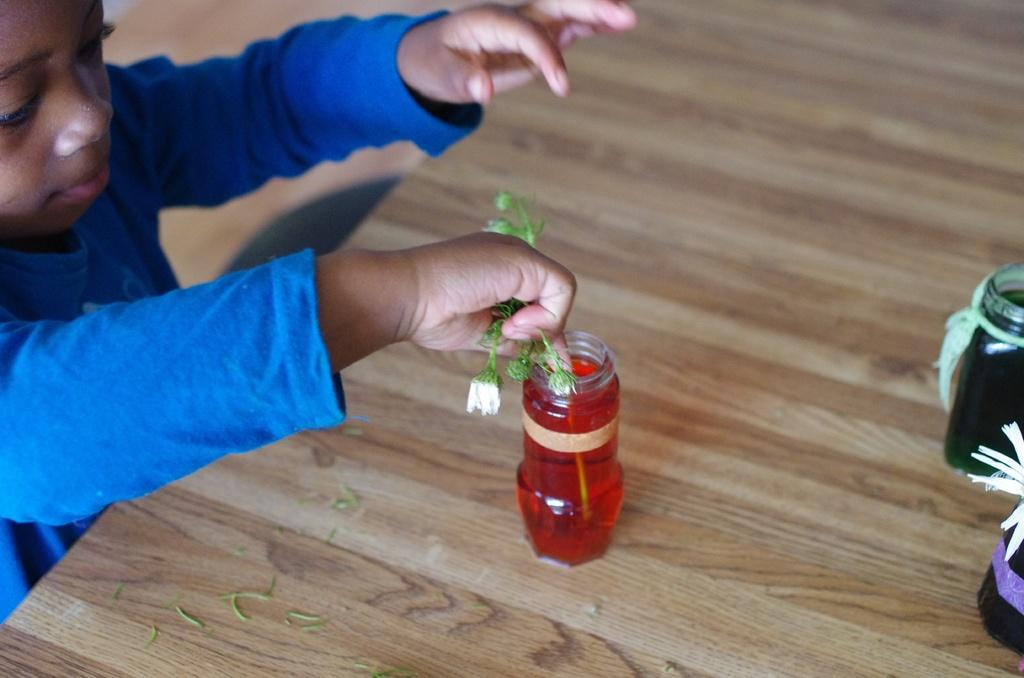What is the main subject of the image? There is a child in the image. What is the child wearing? The child is wearing a blue dress. What is the child holding in the image? The child is holding a plant. What is the child doing with the plant? The child is placing the plant in a bottle. What is the color of the water in the bottle? The water in the bottle is red. How many other bottles are on the table? There are two other bottles on the table. Where are the cows located in the image? There are no cows present in the image. How can the child join the other children in the image? There are no other children present in the image for the child to join. 